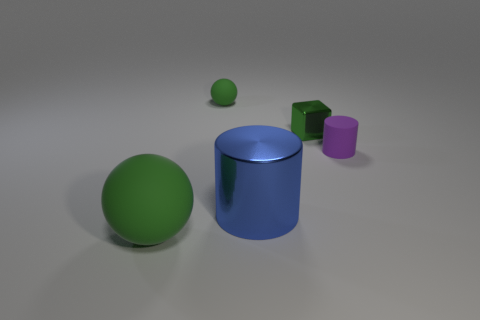What color is the large object on the left side of the green rubber object that is behind the metal cylinder?
Offer a very short reply. Green. There is a cylinder that is the same size as the green block; what color is it?
Give a very brief answer. Purple. What number of big things are gray matte things or balls?
Provide a short and direct response. 1. Is the number of tiny blocks that are right of the big sphere greater than the number of big matte things behind the large blue metal cylinder?
Your answer should be very brief. Yes. The rubber sphere that is the same color as the large rubber object is what size?
Make the answer very short. Small. What number of other objects are the same size as the purple thing?
Make the answer very short. 2. Is the material of the green object that is in front of the tiny cylinder the same as the tiny green sphere?
Make the answer very short. Yes. What number of other things are there of the same color as the block?
Keep it short and to the point. 2. How many other things are there of the same shape as the large rubber thing?
Give a very brief answer. 1. There is a tiny matte thing that is behind the tiny rubber cylinder; is it the same shape as the small rubber thing in front of the tiny green shiny thing?
Provide a short and direct response. No. 